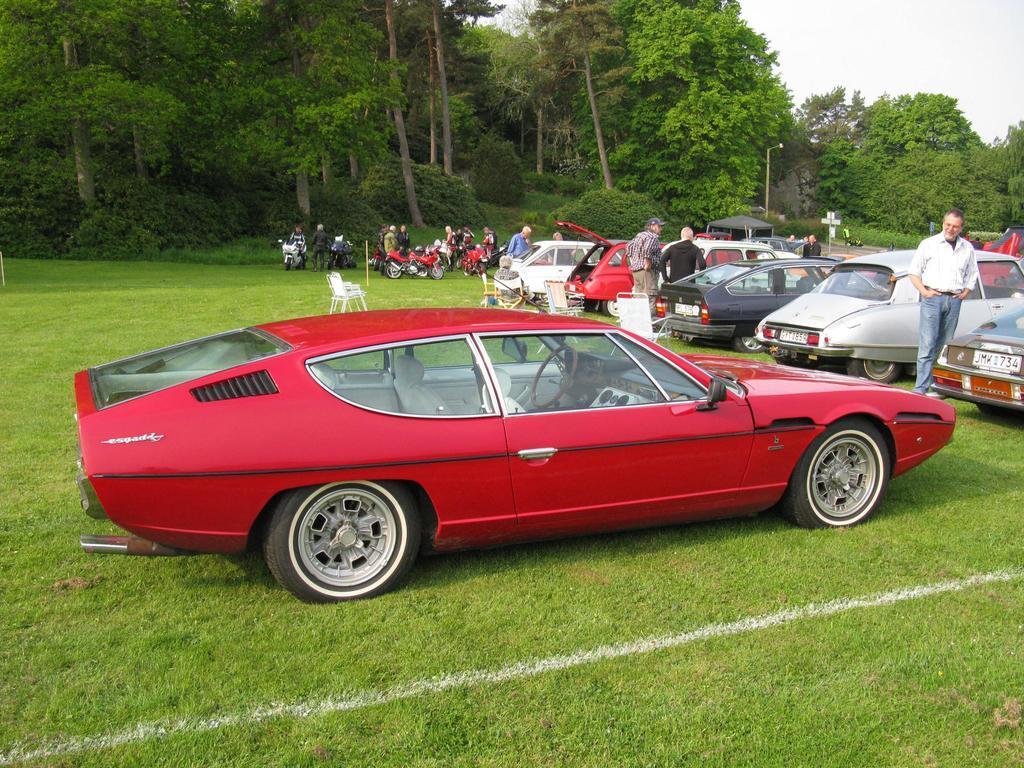How would you summarize this image in a sentence or two? In this image in the front there's grass on the ground. In the center there is a car which is red in colour. On the right side there are cars, there are persons standing and sitting. In the background there are empty chairs, there are persons, there are bikes and trees and the sky is cloudy. 